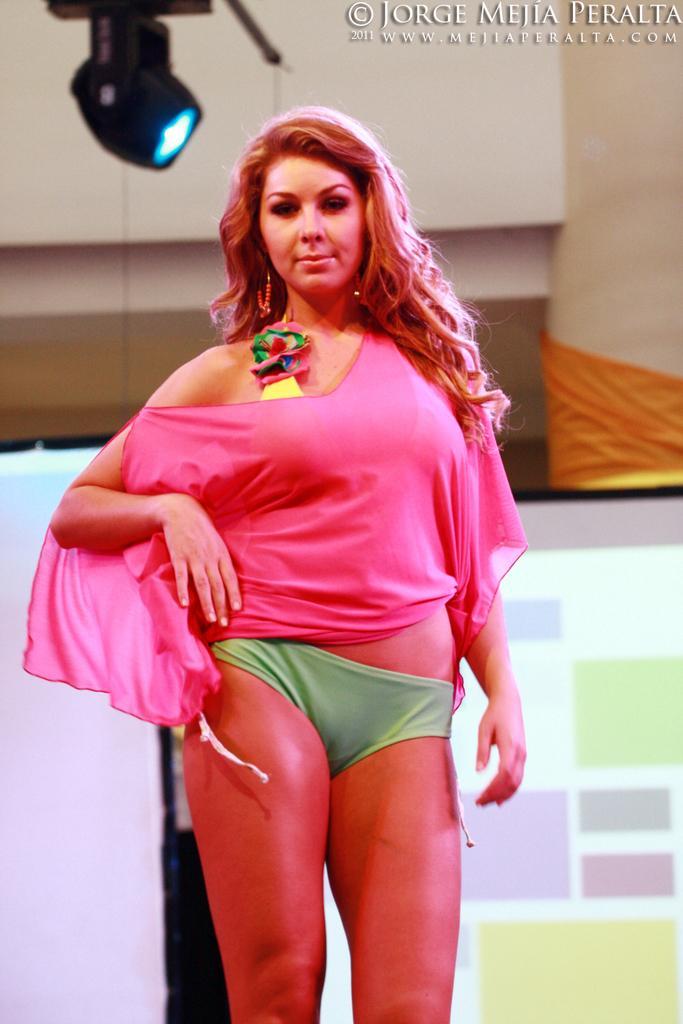Can you describe this image briefly? In this image I can see a woman standing and giving pose for the picture. In the background, I can see a board and wall. At the top of this image I can see a light and some text. 